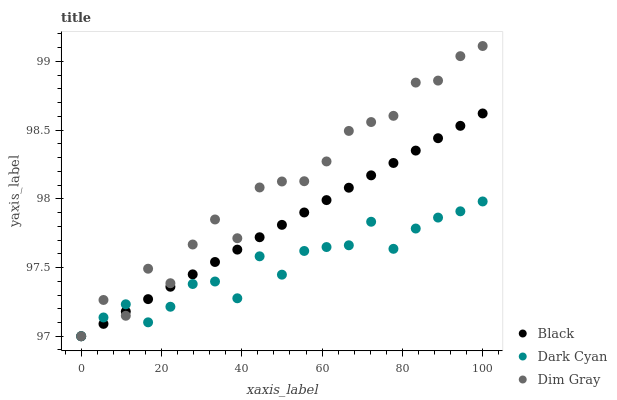Does Dark Cyan have the minimum area under the curve?
Answer yes or no. Yes. Does Dim Gray have the maximum area under the curve?
Answer yes or no. Yes. Does Black have the minimum area under the curve?
Answer yes or no. No. Does Black have the maximum area under the curve?
Answer yes or no. No. Is Black the smoothest?
Answer yes or no. Yes. Is Dim Gray the roughest?
Answer yes or no. Yes. Is Dim Gray the smoothest?
Answer yes or no. No. Is Black the roughest?
Answer yes or no. No. Does Dark Cyan have the lowest value?
Answer yes or no. Yes. Does Dim Gray have the highest value?
Answer yes or no. Yes. Does Black have the highest value?
Answer yes or no. No. Does Black intersect Dark Cyan?
Answer yes or no. Yes. Is Black less than Dark Cyan?
Answer yes or no. No. Is Black greater than Dark Cyan?
Answer yes or no. No. 